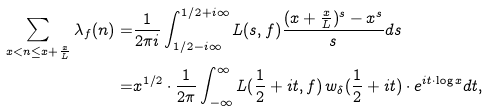Convert formula to latex. <formula><loc_0><loc_0><loc_500><loc_500>\sum _ { x < n \leq x + \frac { x } { L } } \lambda _ { f } ( n ) = & \frac { 1 } { 2 \pi i } \int _ { 1 / 2 - i \infty } ^ { 1 / 2 + i \infty } L ( s , f ) \frac { ( x + \frac { x } { L } ) ^ { s } - x ^ { s } } { s } d s \\ = & x ^ { 1 / 2 } \cdot \frac { 1 } { 2 \pi } \int _ { - \infty } ^ { \infty } L ( \frac { 1 } { 2 } + i t , f ) \, w _ { \delta } ( \frac { 1 } { 2 } + i t ) \cdot e ^ { i t \cdot \log x } d t ,</formula> 